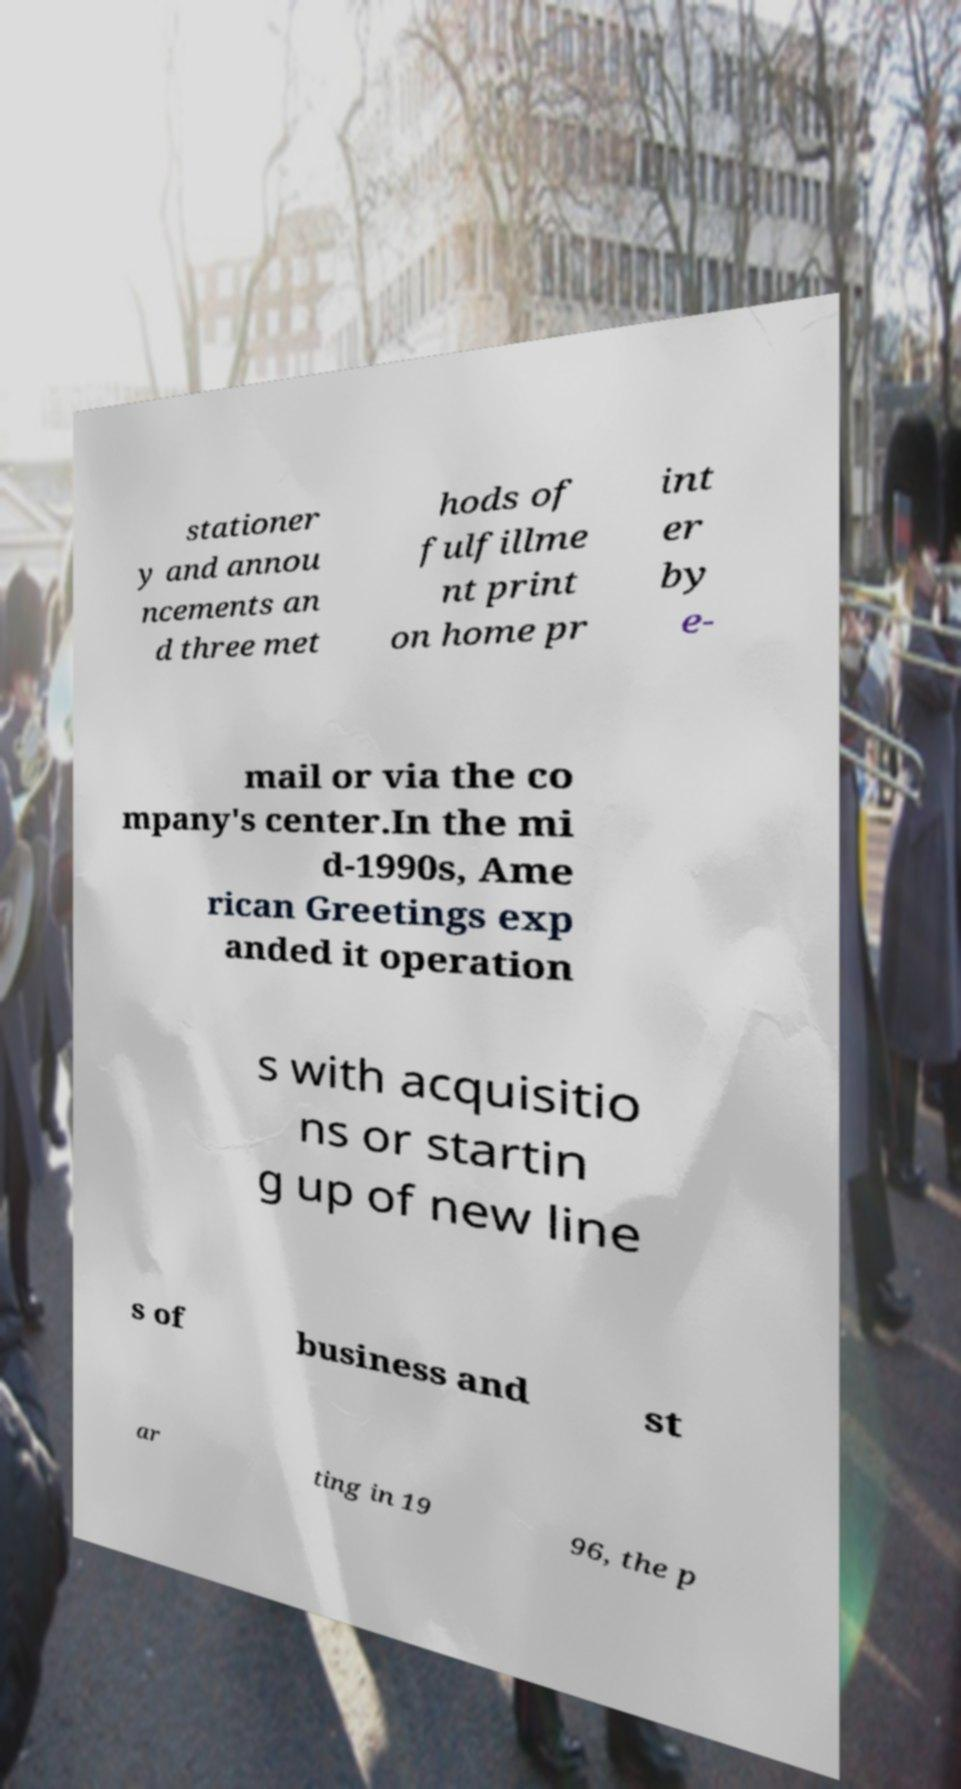What messages or text are displayed in this image? I need them in a readable, typed format. stationer y and annou ncements an d three met hods of fulfillme nt print on home pr int er by e- mail or via the co mpany's center.In the mi d-1990s, Ame rican Greetings exp anded it operation s with acquisitio ns or startin g up of new line s of business and st ar ting in 19 96, the p 